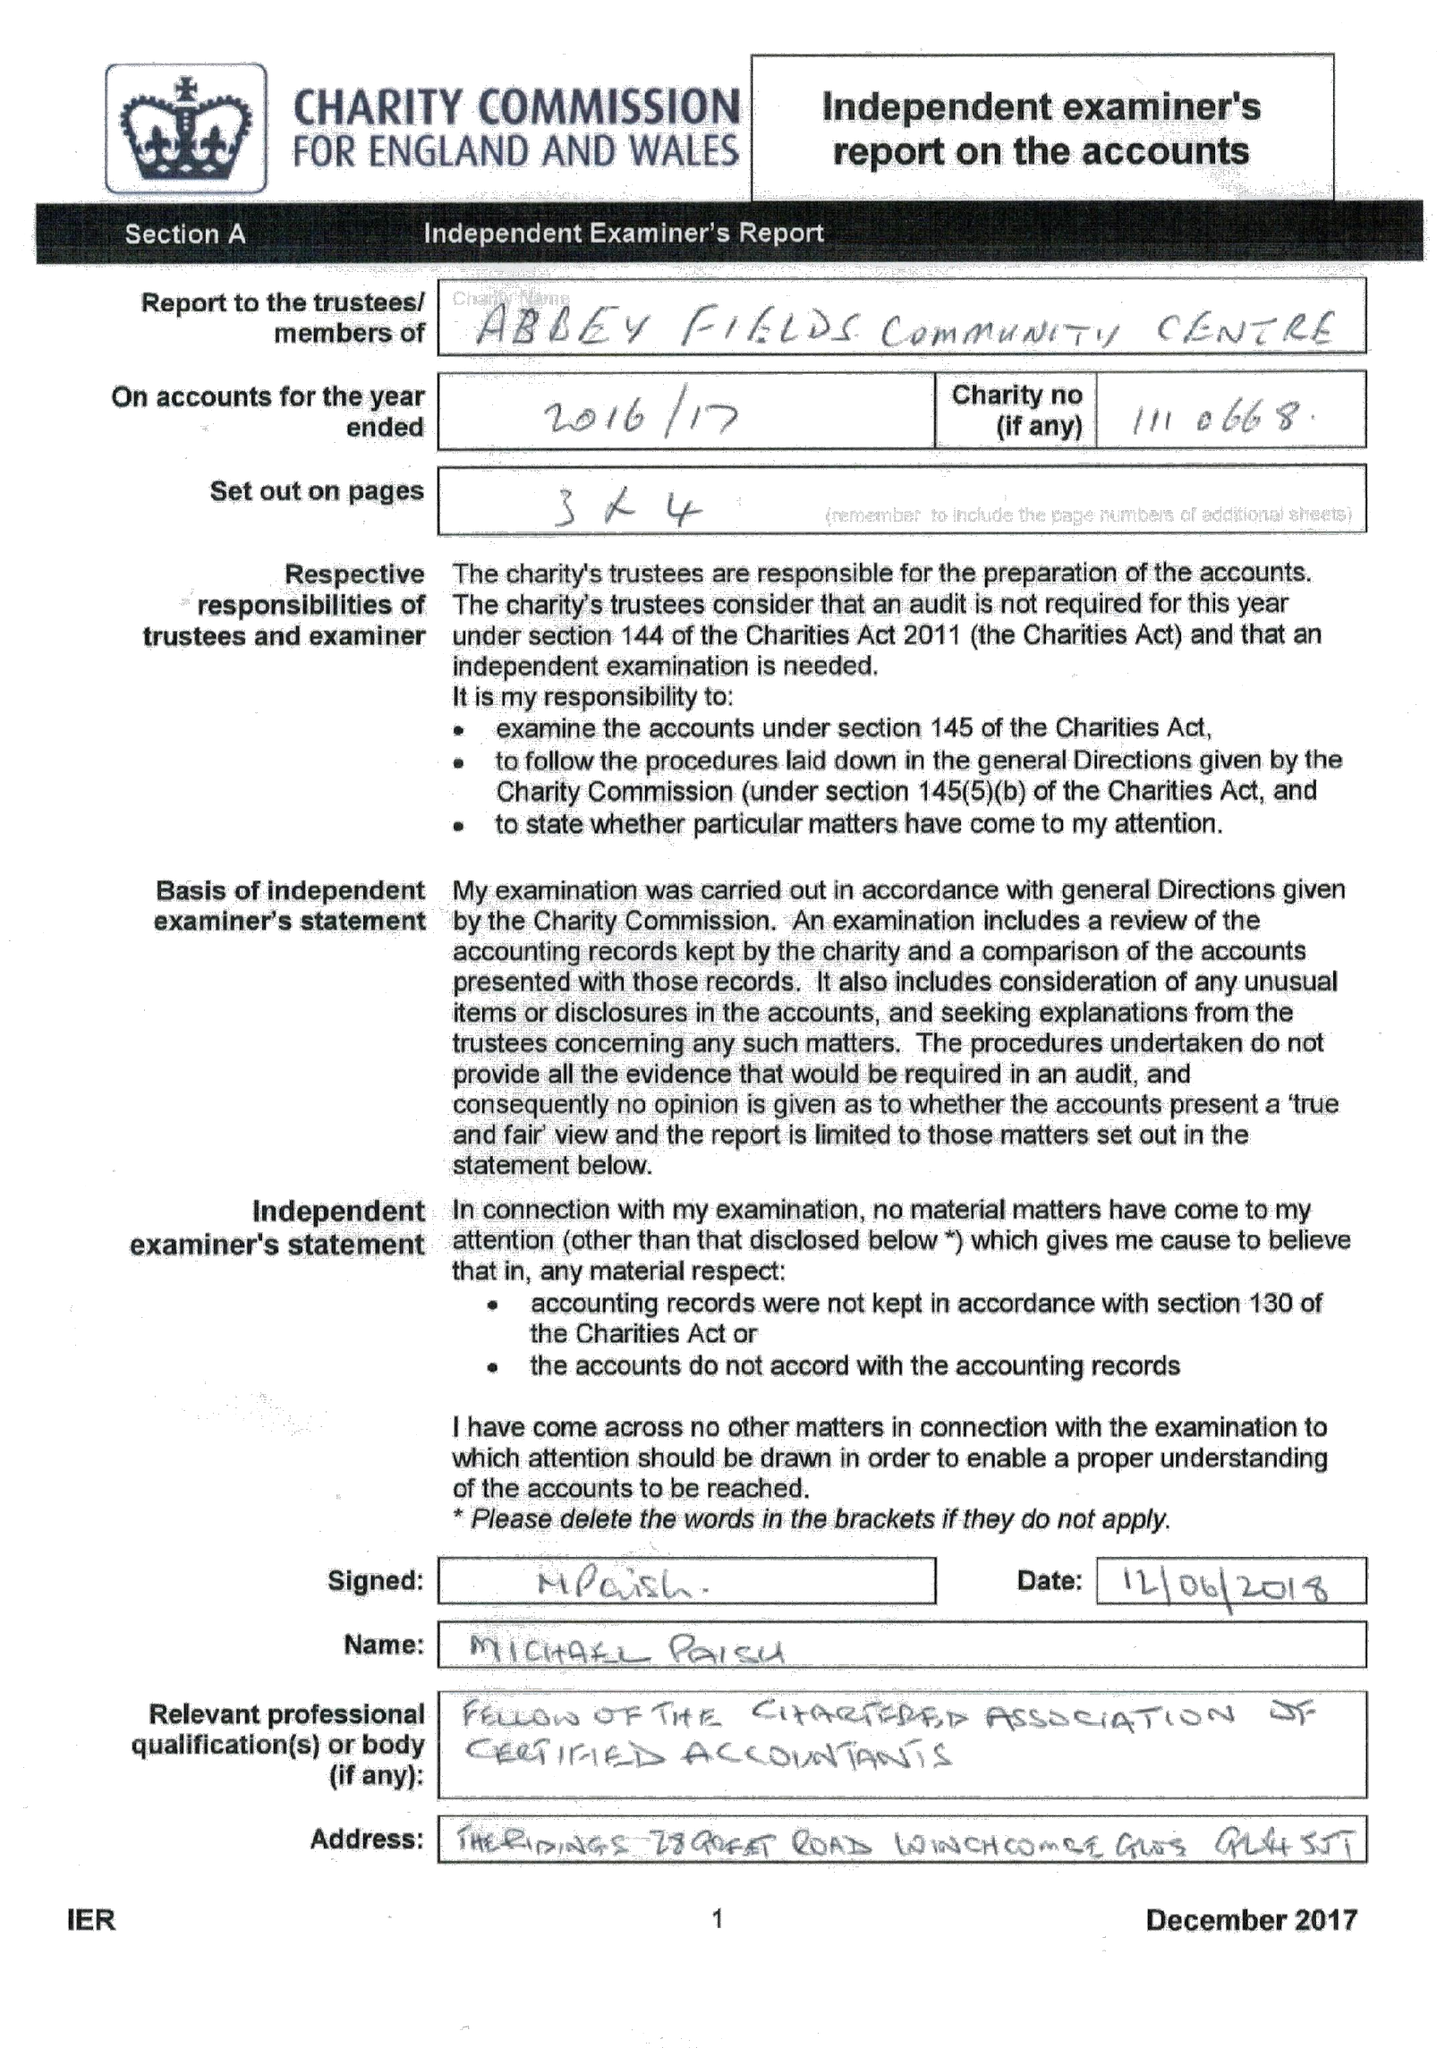What is the value for the charity_number?
Answer the question using a single word or phrase. 1110668 